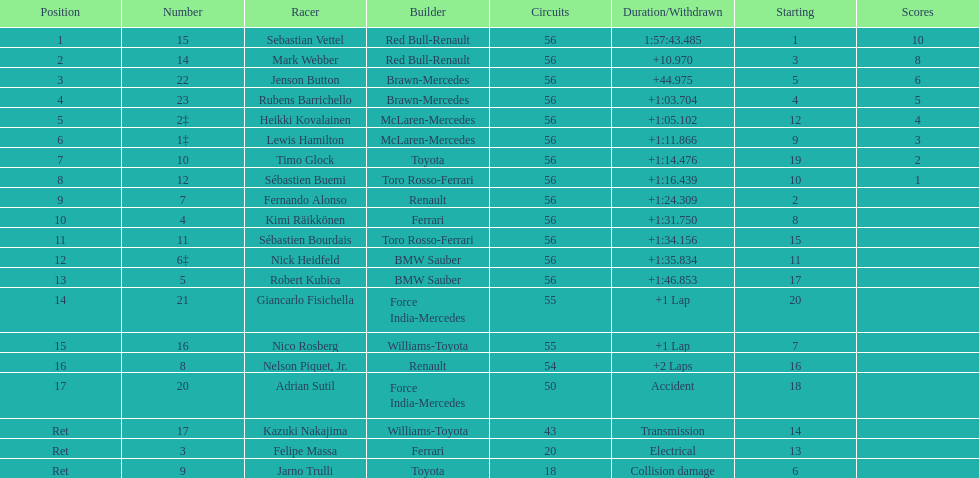What name is just previous to kazuki nakjima on the list? Adrian Sutil. Can you parse all the data within this table? {'header': ['Position', 'Number', 'Racer', 'Builder', 'Circuits', 'Duration/Withdrawn', 'Starting', 'Scores'], 'rows': [['1', '15', 'Sebastian Vettel', 'Red Bull-Renault', '56', '1:57:43.485', '1', '10'], ['2', '14', 'Mark Webber', 'Red Bull-Renault', '56', '+10.970', '3', '8'], ['3', '22', 'Jenson Button', 'Brawn-Mercedes', '56', '+44.975', '5', '6'], ['4', '23', 'Rubens Barrichello', 'Brawn-Mercedes', '56', '+1:03.704', '4', '5'], ['5', '2‡', 'Heikki Kovalainen', 'McLaren-Mercedes', '56', '+1:05.102', '12', '4'], ['6', '1‡', 'Lewis Hamilton', 'McLaren-Mercedes', '56', '+1:11.866', '9', '3'], ['7', '10', 'Timo Glock', 'Toyota', '56', '+1:14.476', '19', '2'], ['8', '12', 'Sébastien Buemi', 'Toro Rosso-Ferrari', '56', '+1:16.439', '10', '1'], ['9', '7', 'Fernando Alonso', 'Renault', '56', '+1:24.309', '2', ''], ['10', '4', 'Kimi Räikkönen', 'Ferrari', '56', '+1:31.750', '8', ''], ['11', '11', 'Sébastien Bourdais', 'Toro Rosso-Ferrari', '56', '+1:34.156', '15', ''], ['12', '6‡', 'Nick Heidfeld', 'BMW Sauber', '56', '+1:35.834', '11', ''], ['13', '5', 'Robert Kubica', 'BMW Sauber', '56', '+1:46.853', '17', ''], ['14', '21', 'Giancarlo Fisichella', 'Force India-Mercedes', '55', '+1 Lap', '20', ''], ['15', '16', 'Nico Rosberg', 'Williams-Toyota', '55', '+1 Lap', '7', ''], ['16', '8', 'Nelson Piquet, Jr.', 'Renault', '54', '+2 Laps', '16', ''], ['17', '20', 'Adrian Sutil', 'Force India-Mercedes', '50', 'Accident', '18', ''], ['Ret', '17', 'Kazuki Nakajima', 'Williams-Toyota', '43', 'Transmission', '14', ''], ['Ret', '3', 'Felipe Massa', 'Ferrari', '20', 'Electrical', '13', ''], ['Ret', '9', 'Jarno Trulli', 'Toyota', '18', 'Collision damage', '6', '']]} 